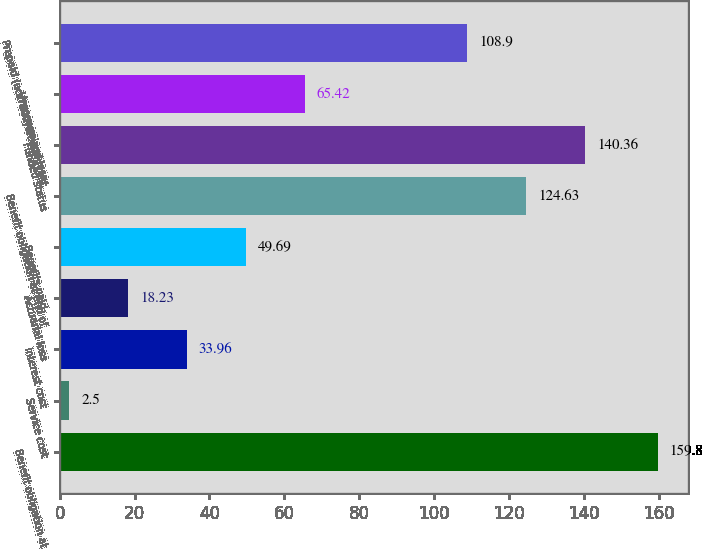<chart> <loc_0><loc_0><loc_500><loc_500><bar_chart><fcel>Benefit obligation at<fcel>Service cost<fcel>Interest cost<fcel>Actuarial loss<fcel>Benefits paid<fcel>Benefit obligation at end of<fcel>Funded status<fcel>Unrecognized loss<fcel>Prepaid (accrued) benefit cost<nl><fcel>159.8<fcel>2.5<fcel>33.96<fcel>18.23<fcel>49.69<fcel>124.63<fcel>140.36<fcel>65.42<fcel>108.9<nl></chart> 